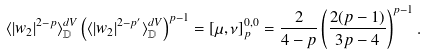<formula> <loc_0><loc_0><loc_500><loc_500>\langle | w _ { 2 } | ^ { 2 - p } \rangle _ { \mathbb { D } } ^ { d V } \left ( \langle | w _ { 2 } | ^ { 2 - p ^ { \prime } } \rangle _ { \mathbb { D } } ^ { d V } \right ) ^ { p - 1 } = [ \mu , \nu ] ^ { 0 , 0 } _ { p } = \frac { 2 } { 4 - p } \left ( \frac { 2 ( p - 1 ) } { 3 p - 4 } \right ) ^ { p - 1 } .</formula> 